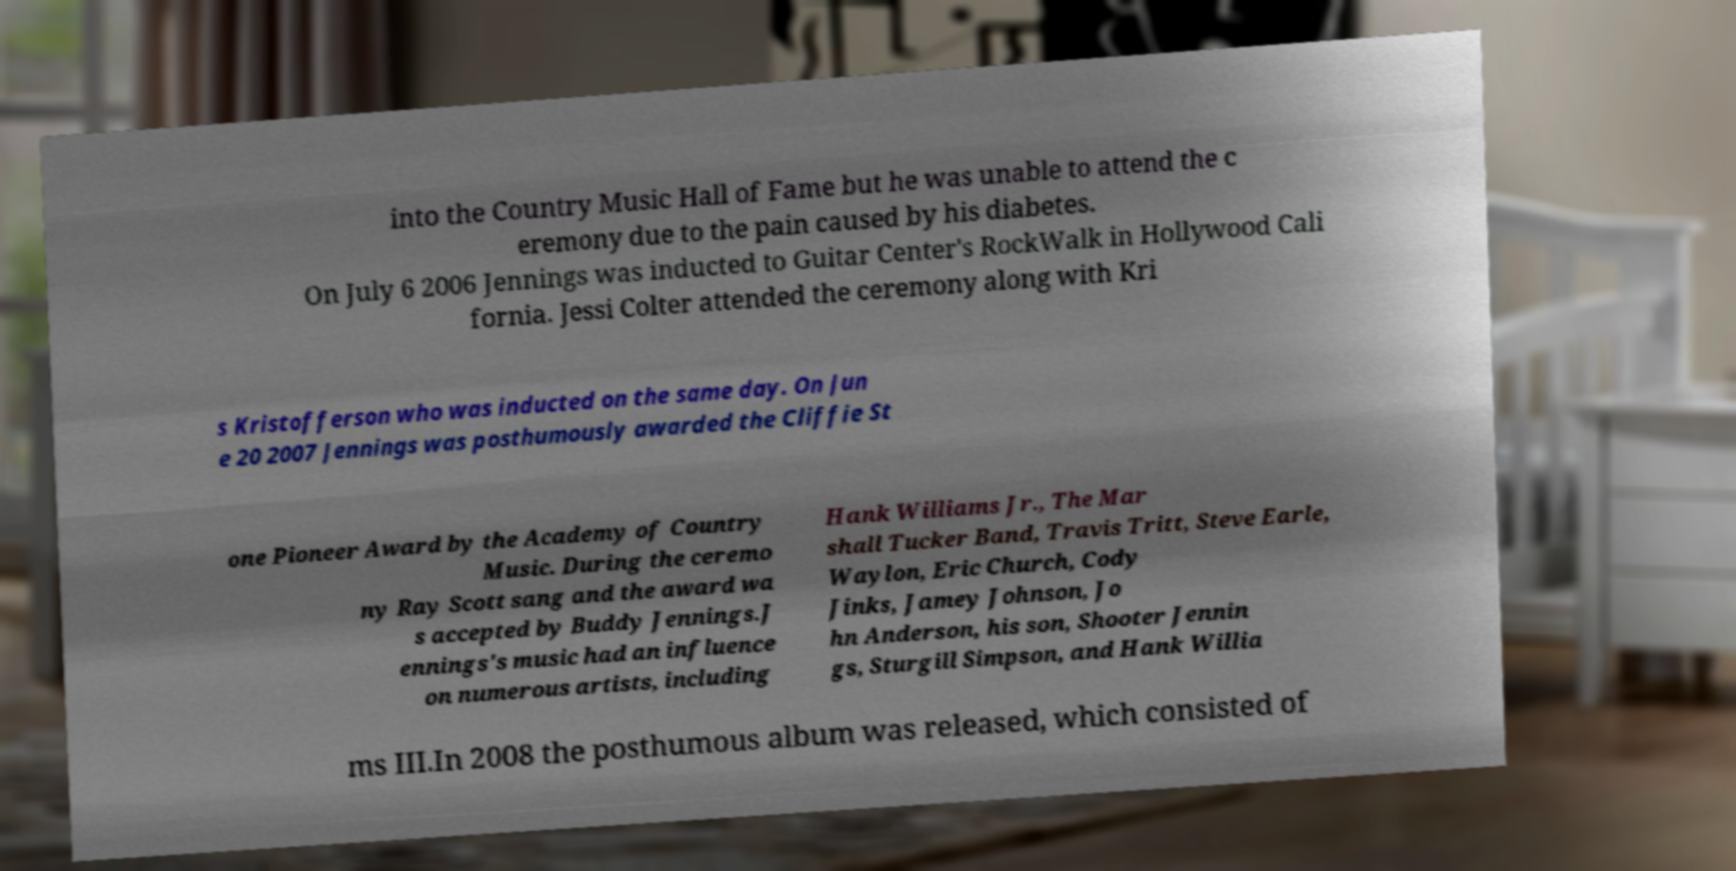I need the written content from this picture converted into text. Can you do that? into the Country Music Hall of Fame but he was unable to attend the c eremony due to the pain caused by his diabetes. On July 6 2006 Jennings was inducted to Guitar Center's RockWalk in Hollywood Cali fornia. Jessi Colter attended the ceremony along with Kri s Kristofferson who was inducted on the same day. On Jun e 20 2007 Jennings was posthumously awarded the Cliffie St one Pioneer Award by the Academy of Country Music. During the ceremo ny Ray Scott sang and the award wa s accepted by Buddy Jennings.J ennings's music had an influence on numerous artists, including Hank Williams Jr., The Mar shall Tucker Band, Travis Tritt, Steve Earle, Waylon, Eric Church, Cody Jinks, Jamey Johnson, Jo hn Anderson, his son, Shooter Jennin gs, Sturgill Simpson, and Hank Willia ms III.In 2008 the posthumous album was released, which consisted of 